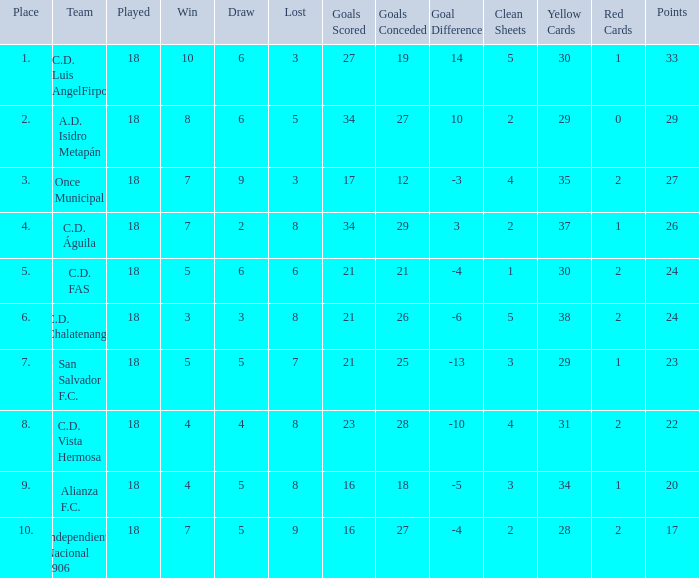What's the place that Once Municipal has a lost greater than 3? None. 